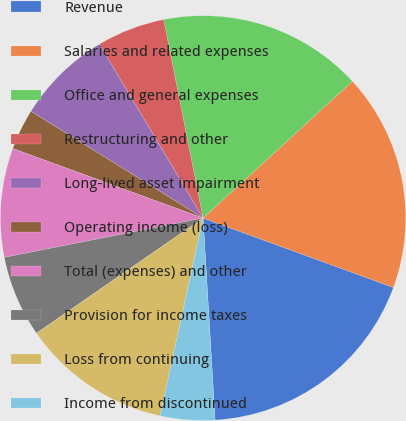<chart> <loc_0><loc_0><loc_500><loc_500><pie_chart><fcel>Revenue<fcel>Salaries and related expenses<fcel>Office and general expenses<fcel>Restructuring and other<fcel>Long-lived asset impairment<fcel>Operating income (loss)<fcel>Total (expenses) and other<fcel>Provision for income taxes<fcel>Loss from continuing<fcel>Income from discontinued<nl><fcel>18.48%<fcel>17.39%<fcel>16.3%<fcel>5.43%<fcel>7.61%<fcel>3.26%<fcel>8.7%<fcel>6.52%<fcel>11.96%<fcel>4.35%<nl></chart> 